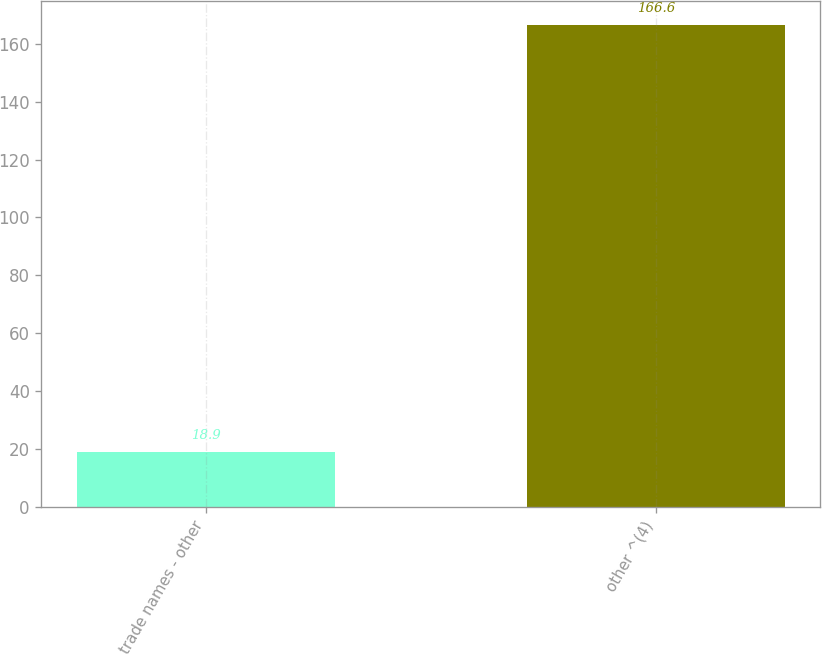<chart> <loc_0><loc_0><loc_500><loc_500><bar_chart><fcel>trade names - other<fcel>other ^(4)<nl><fcel>18.9<fcel>166.6<nl></chart> 